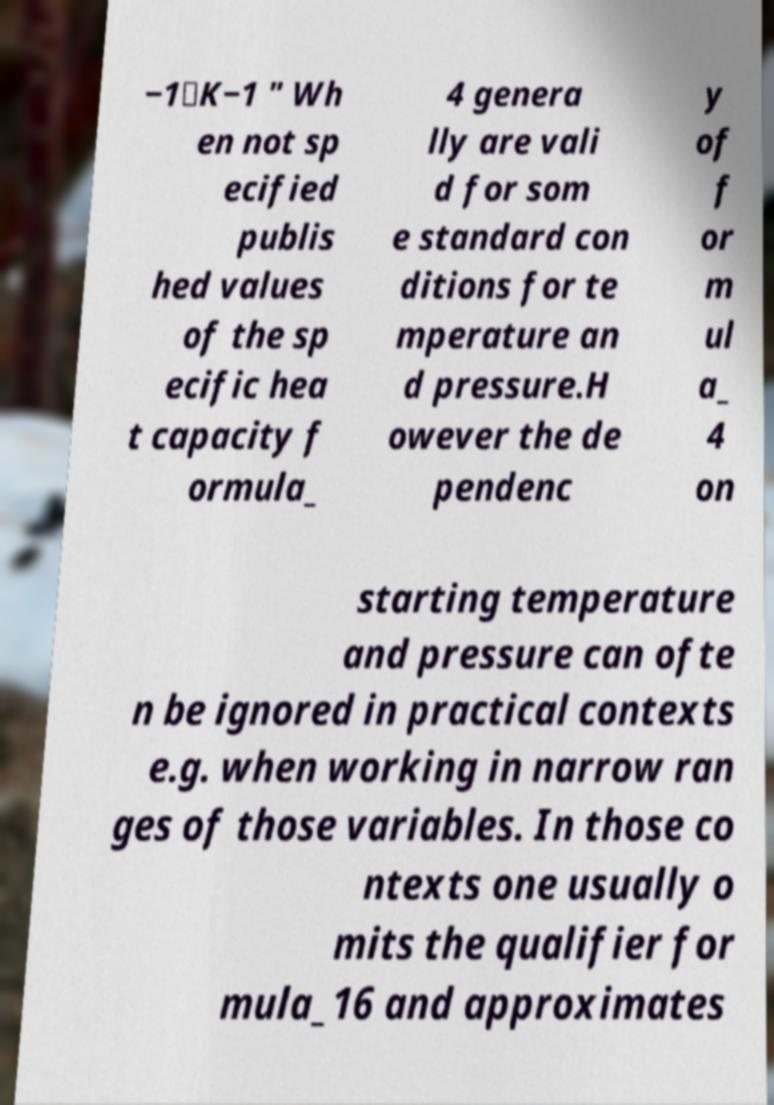Can you read and provide the text displayed in the image?This photo seems to have some interesting text. Can you extract and type it out for me? −1⋅K−1 " Wh en not sp ecified publis hed values of the sp ecific hea t capacity f ormula_ 4 genera lly are vali d for som e standard con ditions for te mperature an d pressure.H owever the de pendenc y of f or m ul a_ 4 on starting temperature and pressure can ofte n be ignored in practical contexts e.g. when working in narrow ran ges of those variables. In those co ntexts one usually o mits the qualifier for mula_16 and approximates 